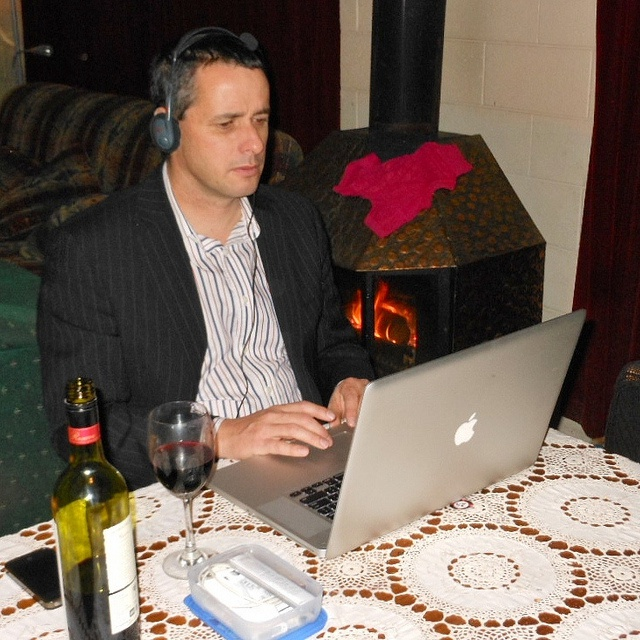Describe the objects in this image and their specific colors. I can see dining table in brown, lightgray, black, tan, and darkgray tones, people in brown, black, salmon, lightgray, and tan tones, laptop in brown, tan, and gray tones, couch in brown, black, and gray tones, and bottle in brown, black, ivory, gray, and olive tones in this image. 